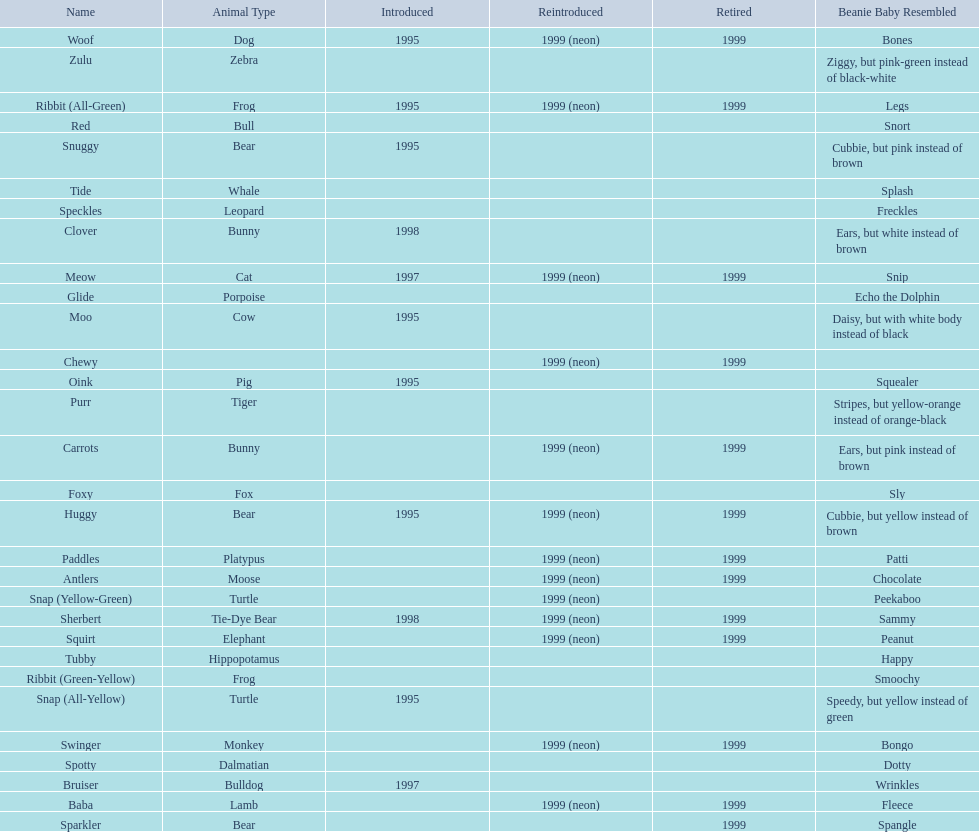What are all the pillow pals? Antlers, Baba, Bruiser, Carrots, Chewy, Clover, Foxy, Glide, Huggy, Meow, Moo, Oink, Paddles, Purr, Red, Ribbit (All-Green), Ribbit (Green-Yellow), Sherbert, Snap (All-Yellow), Snap (Yellow-Green), Snuggy, Sparkler, Speckles, Spotty, Squirt, Swinger, Tide, Tubby, Woof, Zulu. Which is the only without a listed animal type? Chewy. Write the full table. {'header': ['Name', 'Animal Type', 'Introduced', 'Reintroduced', 'Retired', 'Beanie Baby Resembled'], 'rows': [['Woof', 'Dog', '1995', '1999 (neon)', '1999', 'Bones'], ['Zulu', 'Zebra', '', '', '', 'Ziggy, but pink-green instead of black-white'], ['Ribbit (All-Green)', 'Frog', '1995', '1999 (neon)', '1999', 'Legs'], ['Red', 'Bull', '', '', '', 'Snort'], ['Snuggy', 'Bear', '1995', '', '', 'Cubbie, but pink instead of brown'], ['Tide', 'Whale', '', '', '', 'Splash'], ['Speckles', 'Leopard', '', '', '', 'Freckles'], ['Clover', 'Bunny', '1998', '', '', 'Ears, but white instead of brown'], ['Meow', 'Cat', '1997', '1999 (neon)', '1999', 'Snip'], ['Glide', 'Porpoise', '', '', '', 'Echo the Dolphin'], ['Moo', 'Cow', '1995', '', '', 'Daisy, but with white body instead of black'], ['Chewy', '', '', '1999 (neon)', '1999', ''], ['Oink', 'Pig', '1995', '', '', 'Squealer'], ['Purr', 'Tiger', '', '', '', 'Stripes, but yellow-orange instead of orange-black'], ['Carrots', 'Bunny', '', '1999 (neon)', '1999', 'Ears, but pink instead of brown'], ['Foxy', 'Fox', '', '', '', 'Sly'], ['Huggy', 'Bear', '1995', '1999 (neon)', '1999', 'Cubbie, but yellow instead of brown'], ['Paddles', 'Platypus', '', '1999 (neon)', '1999', 'Patti'], ['Antlers', 'Moose', '', '1999 (neon)', '1999', 'Chocolate'], ['Snap (Yellow-Green)', 'Turtle', '', '1999 (neon)', '', 'Peekaboo'], ['Sherbert', 'Tie-Dye Bear', '1998', '1999 (neon)', '1999', 'Sammy'], ['Squirt', 'Elephant', '', '1999 (neon)', '1999', 'Peanut'], ['Tubby', 'Hippopotamus', '', '', '', 'Happy'], ['Ribbit (Green-Yellow)', 'Frog', '', '', '', 'Smoochy'], ['Snap (All-Yellow)', 'Turtle', '1995', '', '', 'Speedy, but yellow instead of green'], ['Swinger', 'Monkey', '', '1999 (neon)', '1999', 'Bongo'], ['Spotty', 'Dalmatian', '', '', '', 'Dotty'], ['Bruiser', 'Bulldog', '1997', '', '', 'Wrinkles'], ['Baba', 'Lamb', '', '1999 (neon)', '1999', 'Fleece'], ['Sparkler', 'Bear', '', '', '1999', 'Spangle']]} 